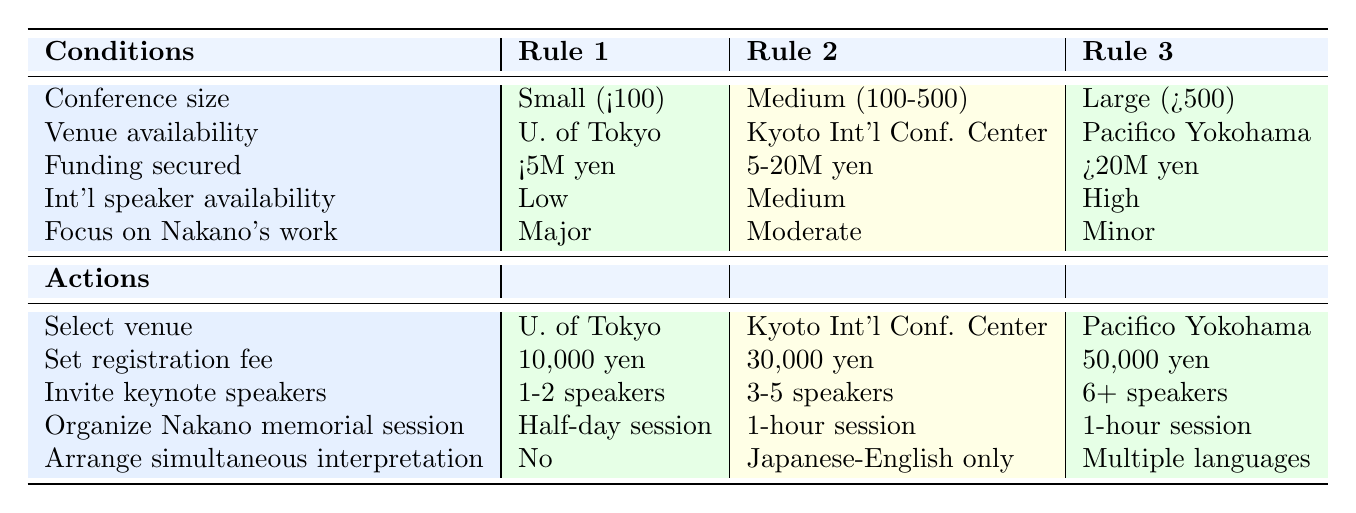What is the registration fee for a large conference held at Pacifico Yokohama? The table states that for a large conference with more than 500 attendees at Pacifico Yokohama, the registration fee is 50,000 yen.
Answer: 50,000 yen What action is planned for the Nakano memorial session in a medium-sized conference? According to the table, for a medium conference at the Kyoto International Conference Center, a 1-hour session is planned for the Nakano memorial session.
Answer: 1-hour session Is simultaneous interpretation arranged for a small conference with low international speaker availability? The table indicates that for a small conference at the University of Tokyo, with low availability of international speakers, no simultaneous interpretation is arranged.
Answer: No How many keynote speakers are invited for a large conference with high international speaker availability? From the table, it shows that for a large conference with high international speaker availability at Pacifico Yokohama, the number of invited keynote speakers is 6 or more.
Answer: 6+ speakers If the focus on Nakano's work is moderate in a medium conference, how much funding is secured? Looking at the conditions for a medium conference with a moderate focus on Nakano's work, it states that the funding secured falls within the range of 5 to 20 million yen.
Answer: 5-20 million yen What is the venue selection for a small conference with major focus on Nakano's work and low international speaker availability? The table specifies that for a small conference with a major focus on Nakano's work and low availability of international speakers, the venue selected is the University of Tokyo.
Answer: University of Tokyo Is the registration fee lower for small conferences compared to medium conferences? By comparing the registration fees in the table, the small conference has a fee of 10,000 yen while the medium conference has a fee of 30,000 yen. Therefore, the fee for the small conference is lower.
Answer: Yes How does the funding required for hosting a medium conference at the Kyoto International Conference Center compare to that of a large conference? The funding for a medium conference is between 5 to 20 million yen, while for a large conference, it is greater than 20 million yen. The comparison shows that the medium conference requires significantly less funding than the large conference.
Answer: Medium conference requires less funding What steps are involved if a large conference is focused on Nakano's work but has low international speaker availability? According to the table, a large conference focused on Nakano's work with low international speaker availability would require identifying the appropriate venue, which would not align with the specified actions since actions indicated for large conferences require high international speaker availability. Therefore, it would represent a mismatch in planning.
Answer: Mismatch in planning 